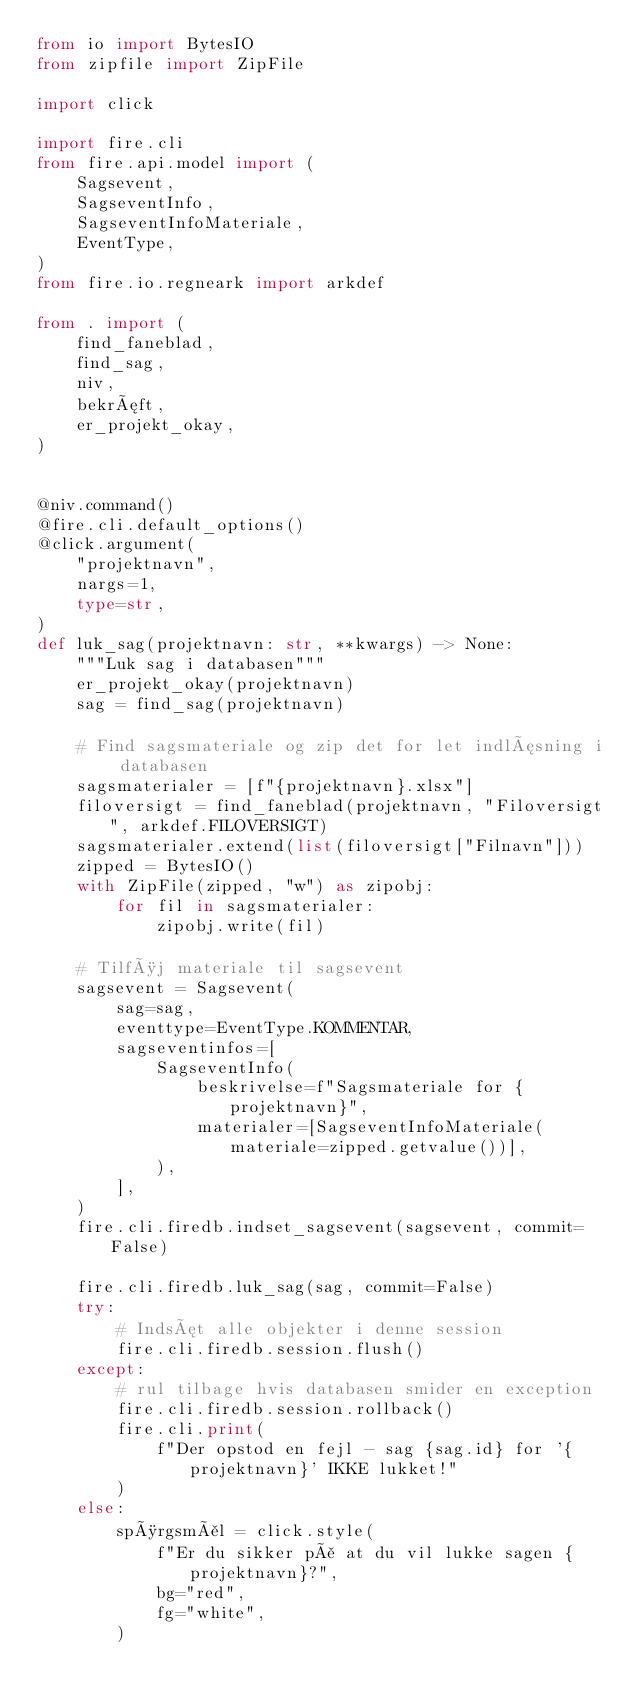Convert code to text. <code><loc_0><loc_0><loc_500><loc_500><_Python_>from io import BytesIO
from zipfile import ZipFile

import click

import fire.cli
from fire.api.model import (
    Sagsevent,
    SagseventInfo,
    SagseventInfoMateriale,
    EventType,
)
from fire.io.regneark import arkdef

from . import (
    find_faneblad,
    find_sag,
    niv,
    bekræft,
    er_projekt_okay,
)


@niv.command()
@fire.cli.default_options()
@click.argument(
    "projektnavn",
    nargs=1,
    type=str,
)
def luk_sag(projektnavn: str, **kwargs) -> None:
    """Luk sag i databasen"""
    er_projekt_okay(projektnavn)
    sag = find_sag(projektnavn)

    # Find sagsmateriale og zip det for let indlæsning i databasen
    sagsmaterialer = [f"{projektnavn}.xlsx"]
    filoversigt = find_faneblad(projektnavn, "Filoversigt", arkdef.FILOVERSIGT)
    sagsmaterialer.extend(list(filoversigt["Filnavn"]))
    zipped = BytesIO()
    with ZipFile(zipped, "w") as zipobj:
        for fil in sagsmaterialer:
            zipobj.write(fil)

    # Tilføj materiale til sagsevent
    sagsevent = Sagsevent(
        sag=sag,
        eventtype=EventType.KOMMENTAR,
        sagseventinfos=[
            SagseventInfo(
                beskrivelse=f"Sagsmateriale for {projektnavn}",
                materialer=[SagseventInfoMateriale(materiale=zipped.getvalue())],
            ),
        ],
    )
    fire.cli.firedb.indset_sagsevent(sagsevent, commit=False)

    fire.cli.firedb.luk_sag(sag, commit=False)
    try:
        # Indsæt alle objekter i denne session
        fire.cli.firedb.session.flush()
    except:
        # rul tilbage hvis databasen smider en exception
        fire.cli.firedb.session.rollback()
        fire.cli.print(
            f"Der opstod en fejl - sag {sag.id} for '{projektnavn}' IKKE lukket!"
        )
    else:
        spørgsmål = click.style(
            f"Er du sikker på at du vil lukke sagen {projektnavn}?",
            bg="red",
            fg="white",
        )</code> 